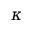<formula> <loc_0><loc_0><loc_500><loc_500>\kappa</formula> 